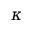<formula> <loc_0><loc_0><loc_500><loc_500>\kappa</formula> 